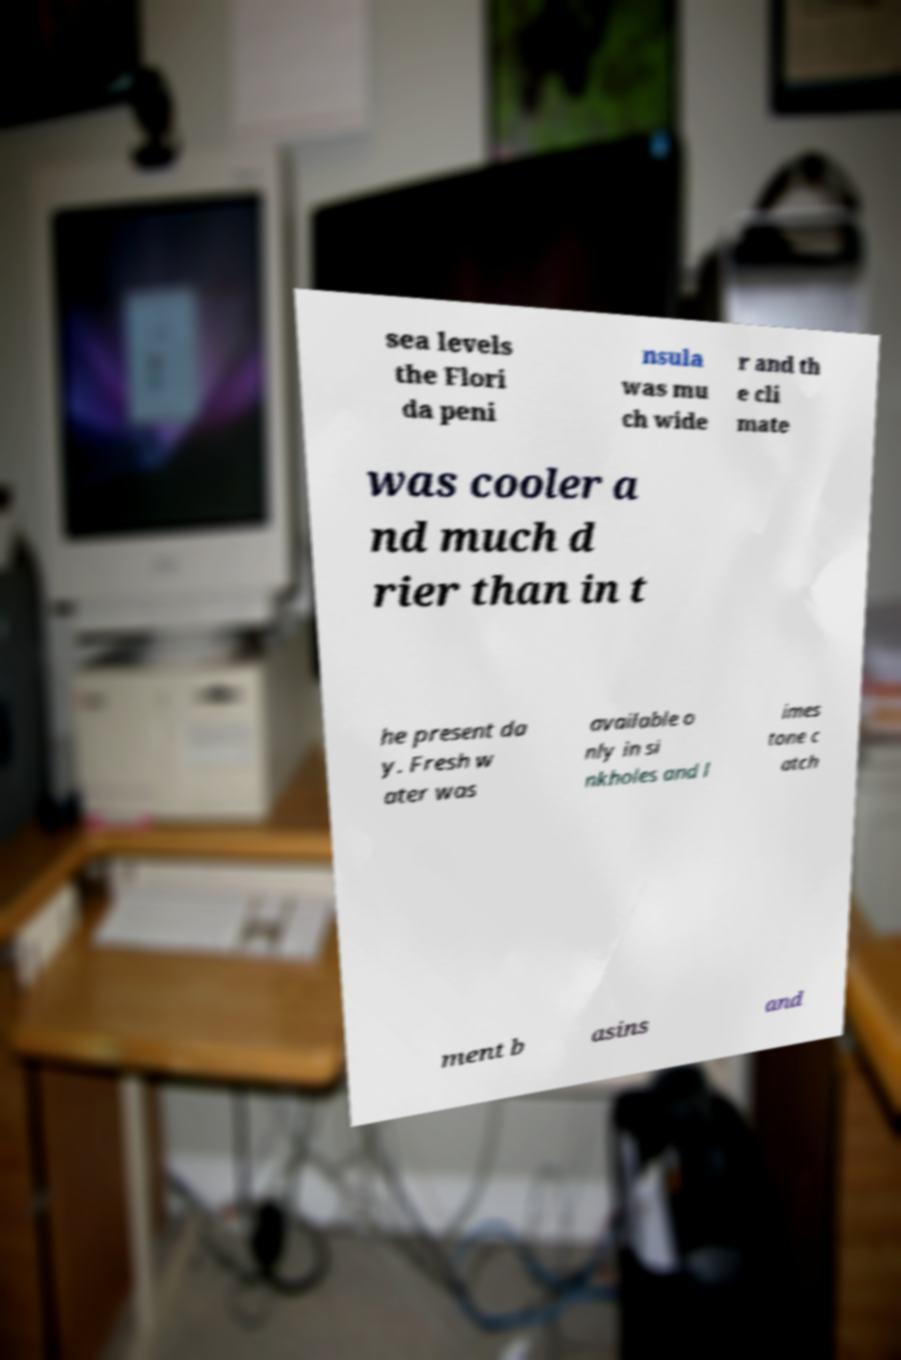Could you assist in decoding the text presented in this image and type it out clearly? sea levels the Flori da peni nsula was mu ch wide r and th e cli mate was cooler a nd much d rier than in t he present da y. Fresh w ater was available o nly in si nkholes and l imes tone c atch ment b asins and 